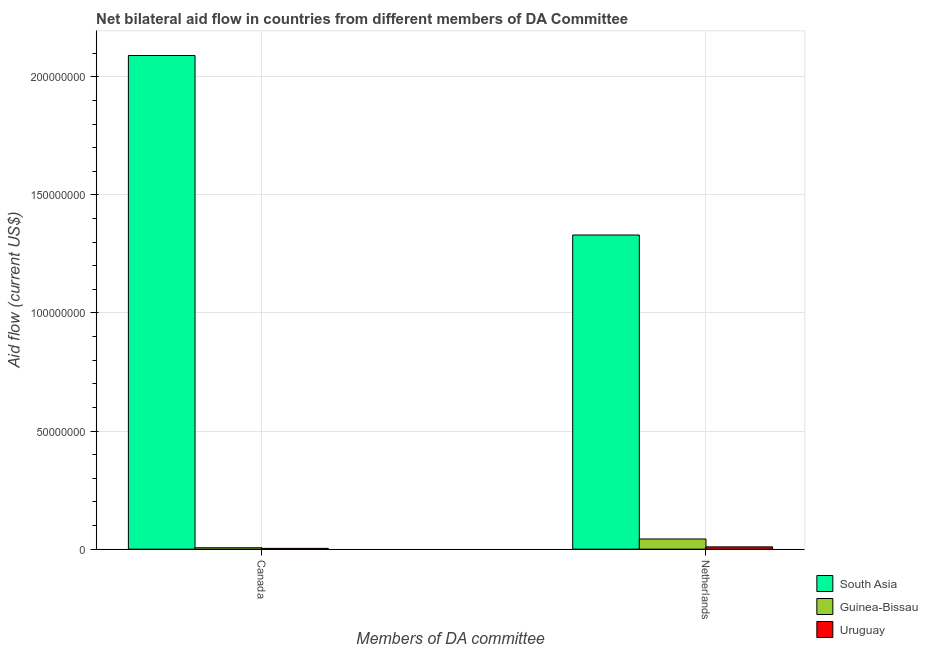How many groups of bars are there?
Offer a terse response. 2. Are the number of bars on each tick of the X-axis equal?
Offer a very short reply. Yes. How many bars are there on the 2nd tick from the left?
Ensure brevity in your answer.  3. How many bars are there on the 1st tick from the right?
Your answer should be compact. 3. What is the label of the 2nd group of bars from the left?
Offer a very short reply. Netherlands. What is the amount of aid given by canada in South Asia?
Give a very brief answer. 2.09e+08. Across all countries, what is the maximum amount of aid given by canada?
Your answer should be compact. 2.09e+08. Across all countries, what is the minimum amount of aid given by netherlands?
Your response must be concise. 9.70e+05. In which country was the amount of aid given by netherlands minimum?
Provide a succinct answer. Uruguay. What is the total amount of aid given by canada in the graph?
Make the answer very short. 2.10e+08. What is the difference between the amount of aid given by canada in Uruguay and that in Guinea-Bissau?
Make the answer very short. -2.70e+05. What is the difference between the amount of aid given by canada in Uruguay and the amount of aid given by netherlands in South Asia?
Provide a succinct answer. -1.33e+08. What is the average amount of aid given by canada per country?
Ensure brevity in your answer.  7.00e+07. What is the difference between the amount of aid given by canada and amount of aid given by netherlands in Guinea-Bissau?
Provide a succinct answer. -3.71e+06. In how many countries, is the amount of aid given by canada greater than 30000000 US$?
Your answer should be very brief. 1. What is the ratio of the amount of aid given by netherlands in South Asia to that in Guinea-Bissau?
Provide a short and direct response. 30.86. Is the amount of aid given by netherlands in Uruguay less than that in Guinea-Bissau?
Your response must be concise. Yes. In how many countries, is the amount of aid given by canada greater than the average amount of aid given by canada taken over all countries?
Provide a short and direct response. 1. What does the 2nd bar from the left in Netherlands represents?
Your answer should be compact. Guinea-Bissau. What does the 1st bar from the right in Canada represents?
Give a very brief answer. Uruguay. How many bars are there?
Your answer should be very brief. 6. How many countries are there in the graph?
Make the answer very short. 3. What is the title of the graph?
Keep it short and to the point. Net bilateral aid flow in countries from different members of DA Committee. What is the label or title of the X-axis?
Provide a succinct answer. Members of DA committee. What is the Aid flow (current US$) in South Asia in Canada?
Make the answer very short. 2.09e+08. What is the Aid flow (current US$) of South Asia in Netherlands?
Your answer should be very brief. 1.33e+08. What is the Aid flow (current US$) of Guinea-Bissau in Netherlands?
Make the answer very short. 4.31e+06. What is the Aid flow (current US$) in Uruguay in Netherlands?
Provide a succinct answer. 9.70e+05. Across all Members of DA committee, what is the maximum Aid flow (current US$) in South Asia?
Your answer should be compact. 2.09e+08. Across all Members of DA committee, what is the maximum Aid flow (current US$) in Guinea-Bissau?
Ensure brevity in your answer.  4.31e+06. Across all Members of DA committee, what is the maximum Aid flow (current US$) in Uruguay?
Your answer should be very brief. 9.70e+05. Across all Members of DA committee, what is the minimum Aid flow (current US$) in South Asia?
Your answer should be very brief. 1.33e+08. Across all Members of DA committee, what is the minimum Aid flow (current US$) in Guinea-Bissau?
Offer a terse response. 6.00e+05. Across all Members of DA committee, what is the minimum Aid flow (current US$) of Uruguay?
Make the answer very short. 3.30e+05. What is the total Aid flow (current US$) in South Asia in the graph?
Your answer should be compact. 3.42e+08. What is the total Aid flow (current US$) of Guinea-Bissau in the graph?
Make the answer very short. 4.91e+06. What is the total Aid flow (current US$) in Uruguay in the graph?
Make the answer very short. 1.30e+06. What is the difference between the Aid flow (current US$) of South Asia in Canada and that in Netherlands?
Provide a short and direct response. 7.60e+07. What is the difference between the Aid flow (current US$) of Guinea-Bissau in Canada and that in Netherlands?
Provide a short and direct response. -3.71e+06. What is the difference between the Aid flow (current US$) of Uruguay in Canada and that in Netherlands?
Offer a very short reply. -6.40e+05. What is the difference between the Aid flow (current US$) in South Asia in Canada and the Aid flow (current US$) in Guinea-Bissau in Netherlands?
Provide a short and direct response. 2.05e+08. What is the difference between the Aid flow (current US$) in South Asia in Canada and the Aid flow (current US$) in Uruguay in Netherlands?
Your answer should be compact. 2.08e+08. What is the difference between the Aid flow (current US$) in Guinea-Bissau in Canada and the Aid flow (current US$) in Uruguay in Netherlands?
Make the answer very short. -3.70e+05. What is the average Aid flow (current US$) of South Asia per Members of DA committee?
Offer a terse response. 1.71e+08. What is the average Aid flow (current US$) in Guinea-Bissau per Members of DA committee?
Your response must be concise. 2.46e+06. What is the average Aid flow (current US$) in Uruguay per Members of DA committee?
Offer a terse response. 6.50e+05. What is the difference between the Aid flow (current US$) in South Asia and Aid flow (current US$) in Guinea-Bissau in Canada?
Make the answer very short. 2.08e+08. What is the difference between the Aid flow (current US$) in South Asia and Aid flow (current US$) in Uruguay in Canada?
Ensure brevity in your answer.  2.09e+08. What is the difference between the Aid flow (current US$) of Guinea-Bissau and Aid flow (current US$) of Uruguay in Canada?
Provide a succinct answer. 2.70e+05. What is the difference between the Aid flow (current US$) in South Asia and Aid flow (current US$) in Guinea-Bissau in Netherlands?
Your answer should be very brief. 1.29e+08. What is the difference between the Aid flow (current US$) of South Asia and Aid flow (current US$) of Uruguay in Netherlands?
Provide a short and direct response. 1.32e+08. What is the difference between the Aid flow (current US$) of Guinea-Bissau and Aid flow (current US$) of Uruguay in Netherlands?
Your answer should be compact. 3.34e+06. What is the ratio of the Aid flow (current US$) of South Asia in Canada to that in Netherlands?
Provide a succinct answer. 1.57. What is the ratio of the Aid flow (current US$) of Guinea-Bissau in Canada to that in Netherlands?
Offer a terse response. 0.14. What is the ratio of the Aid flow (current US$) in Uruguay in Canada to that in Netherlands?
Give a very brief answer. 0.34. What is the difference between the highest and the second highest Aid flow (current US$) in South Asia?
Ensure brevity in your answer.  7.60e+07. What is the difference between the highest and the second highest Aid flow (current US$) in Guinea-Bissau?
Keep it short and to the point. 3.71e+06. What is the difference between the highest and the second highest Aid flow (current US$) in Uruguay?
Your answer should be very brief. 6.40e+05. What is the difference between the highest and the lowest Aid flow (current US$) in South Asia?
Your response must be concise. 7.60e+07. What is the difference between the highest and the lowest Aid flow (current US$) in Guinea-Bissau?
Make the answer very short. 3.71e+06. What is the difference between the highest and the lowest Aid flow (current US$) in Uruguay?
Give a very brief answer. 6.40e+05. 